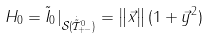Convert formula to latex. <formula><loc_0><loc_0><loc_500><loc_500>H _ { 0 } = \tilde { I } _ { 0 } | _ { \mathcal { S } ( \dot { \tilde { \mathcal { T } } } _ { + - } ^ { 0 } ) } = \left \| \vec { x } \right \| ( 1 + \vec { y } ^ { 2 } )</formula> 